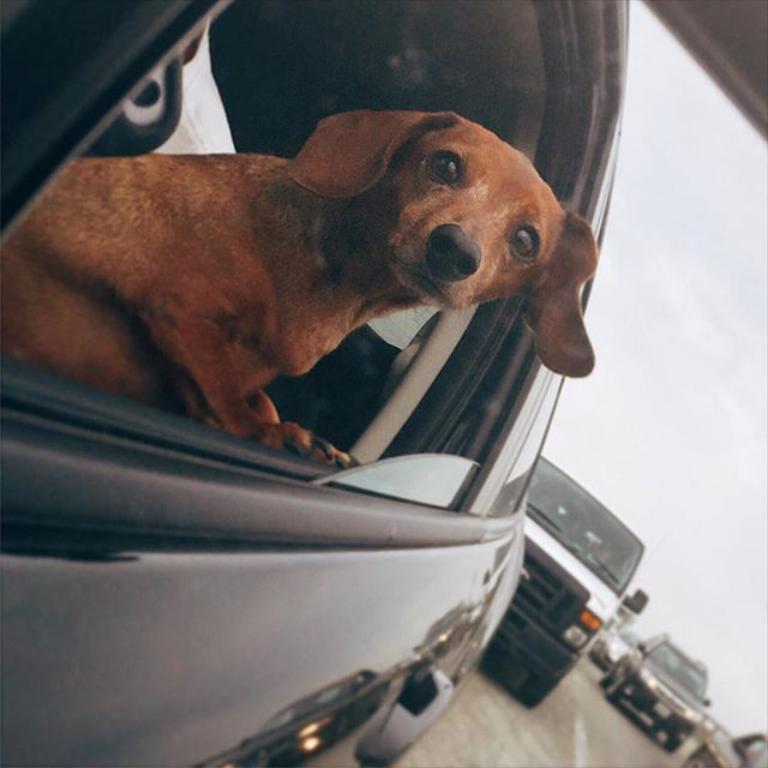Describe this image in one or two sentences. In this image we can see a dog which is inside the car. In the background we can see a few cars which are on the road. 